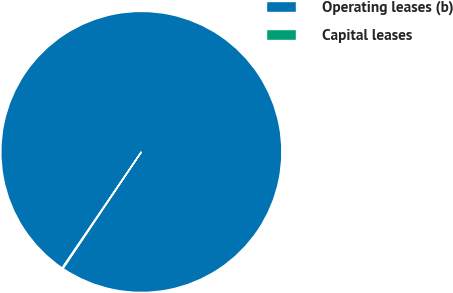Convert chart. <chart><loc_0><loc_0><loc_500><loc_500><pie_chart><fcel>Operating leases (b)<fcel>Capital leases<nl><fcel>99.89%<fcel>0.11%<nl></chart> 